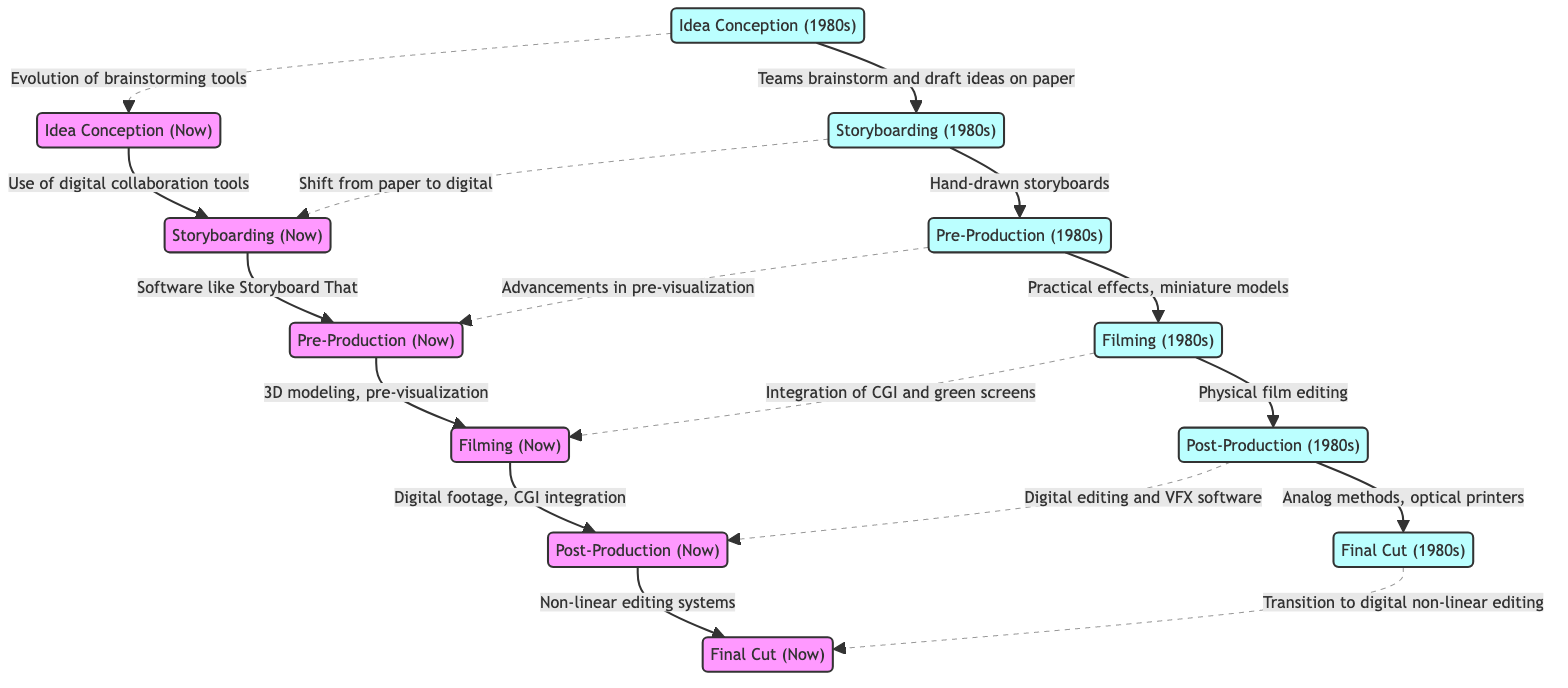What is the first stage of the workflow in the 1980s? The first stage in the 1980s is labeled "Idea Conception (1980s)". This can be found at the top of the left side of the diagram.
Answer: Idea Conception (1980s) What tool is used for storyboarding in the current workflow? In the current workflow (Now), the tool used for storyboarding is mentioned as "Software like Storyboard That or FrameForge". This is specifically indicated as the connection from the node "Now-Storyboarding" to "Now-PreProduction".
Answer: Software like Storyboard That or FrameForge How many nodes represent the final cut stage? The diagram has two nodes representing the final cut stage: "Final Cut (1980s)" and "Final Cut (Now)". Each is dedicated to their respective time period in the workflow.
Answer: 2 What connects the Idea Conception (1980s) and Storyboarding (Now)? The connection is labeled "Evolution of brainstorming tools", representing a transition from the 1980s to the present. This is indicated in the diagram by a dashed line.
Answer: Evolution of brainstorming tools In the 1980s, what method was used for editing in post-production? The method used for editing in post-production during the 1980s is labeled "Analog methods for editing and effects, optical printers". This is indicated as the connection from "1980s-PostProduction" to "1980s-FinalCut".
Answer: Analog methods for editing and effects, optical printers What is indicated as the main difference in filming from the 1980s to now? The main difference indicated is "Integration of CGI and green screens", which connects "1980s-Filming" to "Now-Filming". This shows how technology in filming has advanced over the years.
Answer: Integration of CGI and green screens Which node represents practical effects in the production workflow? The node representing practical effects is labeled "Practical effects, miniature models", which links "1980s-PreProduction" to "1980s-Filming". This specifies the traditional production methods used during that era.
Answer: Practical effects, miniature models How has storyboarding changed from the 1980s to now? The change is depicted by the shift from "Hand-drawn storyboards" to "Software like Storyboard That or FrameForge". This is captured by the connection going from "1980s-Storyboarding" to "Now-Storyboarding".
Answer: Shift from paper to digital What type of editing system is used in the current workflow? The current workflow utilizes "Non-linear editing systems like Adobe Premiere, Final Cut Pro" for final cut, indicated through the connection from "Now-PostProduction" to "Now-FinalCut".
Answer: Non-linear editing systems like Adobe Premiere, Final Cut Pro 